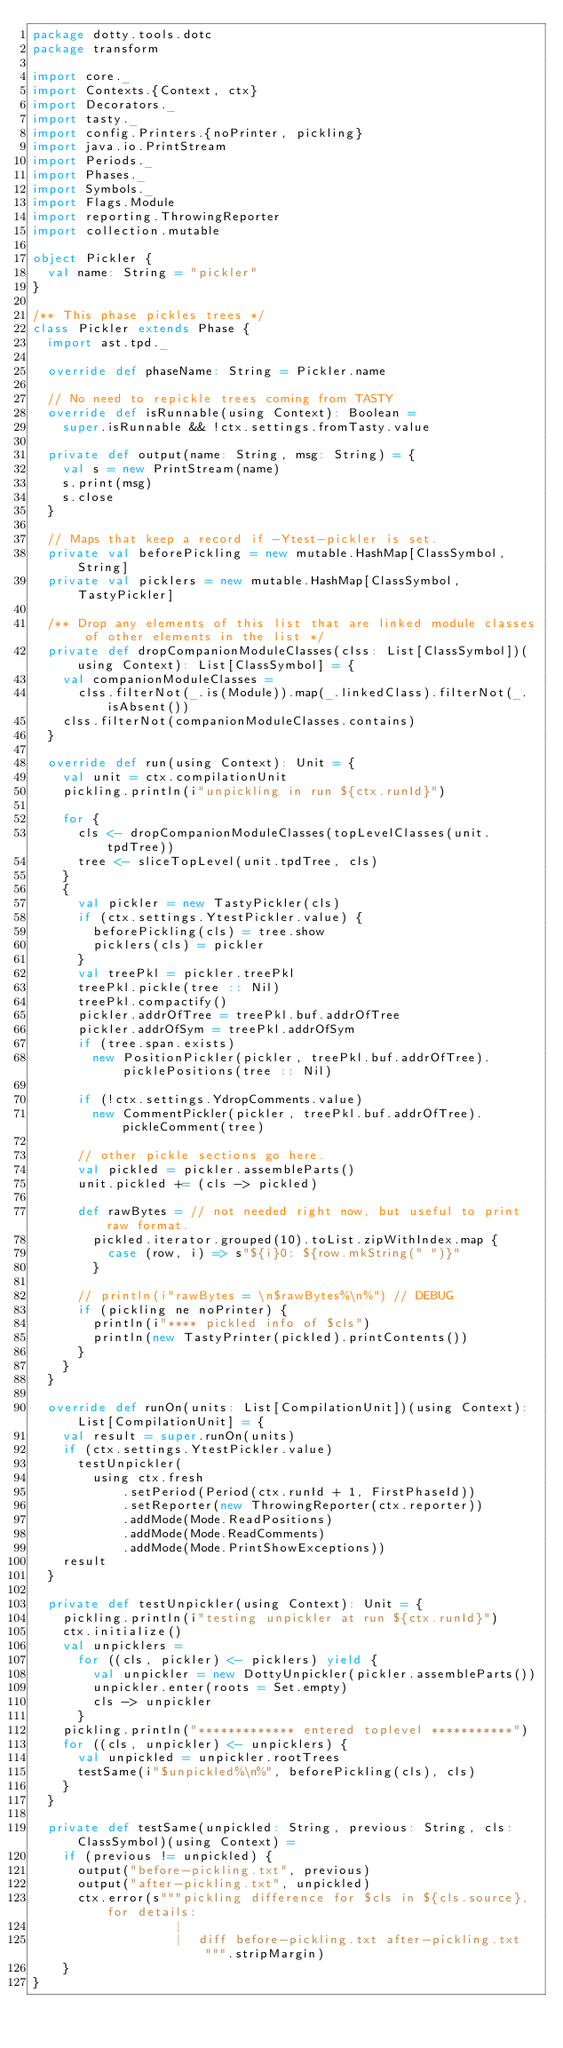<code> <loc_0><loc_0><loc_500><loc_500><_Scala_>package dotty.tools.dotc
package transform

import core._
import Contexts.{Context, ctx}
import Decorators._
import tasty._
import config.Printers.{noPrinter, pickling}
import java.io.PrintStream
import Periods._
import Phases._
import Symbols._
import Flags.Module
import reporting.ThrowingReporter
import collection.mutable

object Pickler {
  val name: String = "pickler"
}

/** This phase pickles trees */
class Pickler extends Phase {
  import ast.tpd._

  override def phaseName: String = Pickler.name

  // No need to repickle trees coming from TASTY
  override def isRunnable(using Context): Boolean =
    super.isRunnable && !ctx.settings.fromTasty.value

  private def output(name: String, msg: String) = {
    val s = new PrintStream(name)
    s.print(msg)
    s.close
  }

  // Maps that keep a record if -Ytest-pickler is set.
  private val beforePickling = new mutable.HashMap[ClassSymbol, String]
  private val picklers = new mutable.HashMap[ClassSymbol, TastyPickler]

  /** Drop any elements of this list that are linked module classes of other elements in the list */
  private def dropCompanionModuleClasses(clss: List[ClassSymbol])(using Context): List[ClassSymbol] = {
    val companionModuleClasses =
      clss.filterNot(_.is(Module)).map(_.linkedClass).filterNot(_.isAbsent())
    clss.filterNot(companionModuleClasses.contains)
  }

  override def run(using Context): Unit = {
    val unit = ctx.compilationUnit
    pickling.println(i"unpickling in run ${ctx.runId}")

    for {
      cls <- dropCompanionModuleClasses(topLevelClasses(unit.tpdTree))
      tree <- sliceTopLevel(unit.tpdTree, cls)
    }
    {
      val pickler = new TastyPickler(cls)
      if (ctx.settings.YtestPickler.value) {
        beforePickling(cls) = tree.show
        picklers(cls) = pickler
      }
      val treePkl = pickler.treePkl
      treePkl.pickle(tree :: Nil)
      treePkl.compactify()
      pickler.addrOfTree = treePkl.buf.addrOfTree
      pickler.addrOfSym = treePkl.addrOfSym
      if (tree.span.exists)
        new PositionPickler(pickler, treePkl.buf.addrOfTree).picklePositions(tree :: Nil)

      if (!ctx.settings.YdropComments.value)
        new CommentPickler(pickler, treePkl.buf.addrOfTree).pickleComment(tree)

      // other pickle sections go here.
      val pickled = pickler.assembleParts()
      unit.pickled += (cls -> pickled)

      def rawBytes = // not needed right now, but useful to print raw format.
        pickled.iterator.grouped(10).toList.zipWithIndex.map {
          case (row, i) => s"${i}0: ${row.mkString(" ")}"
        }

      // println(i"rawBytes = \n$rawBytes%\n%") // DEBUG
      if (pickling ne noPrinter) {
        println(i"**** pickled info of $cls")
        println(new TastyPrinter(pickled).printContents())
      }
    }
  }

  override def runOn(units: List[CompilationUnit])(using Context): List[CompilationUnit] = {
    val result = super.runOn(units)
    if (ctx.settings.YtestPickler.value)
      testUnpickler(
        using ctx.fresh
            .setPeriod(Period(ctx.runId + 1, FirstPhaseId))
            .setReporter(new ThrowingReporter(ctx.reporter))
            .addMode(Mode.ReadPositions)
            .addMode(Mode.ReadComments)
            .addMode(Mode.PrintShowExceptions))
    result
  }

  private def testUnpickler(using Context): Unit = {
    pickling.println(i"testing unpickler at run ${ctx.runId}")
    ctx.initialize()
    val unpicklers =
      for ((cls, pickler) <- picklers) yield {
        val unpickler = new DottyUnpickler(pickler.assembleParts())
        unpickler.enter(roots = Set.empty)
        cls -> unpickler
      }
    pickling.println("************* entered toplevel ***********")
    for ((cls, unpickler) <- unpicklers) {
      val unpickled = unpickler.rootTrees
      testSame(i"$unpickled%\n%", beforePickling(cls), cls)
    }
  }

  private def testSame(unpickled: String, previous: String, cls: ClassSymbol)(using Context) =
    if (previous != unpickled) {
      output("before-pickling.txt", previous)
      output("after-pickling.txt", unpickled)
      ctx.error(s"""pickling difference for $cls in ${cls.source}, for details:
                   |
                   |  diff before-pickling.txt after-pickling.txt""".stripMargin)
    }
}
</code> 